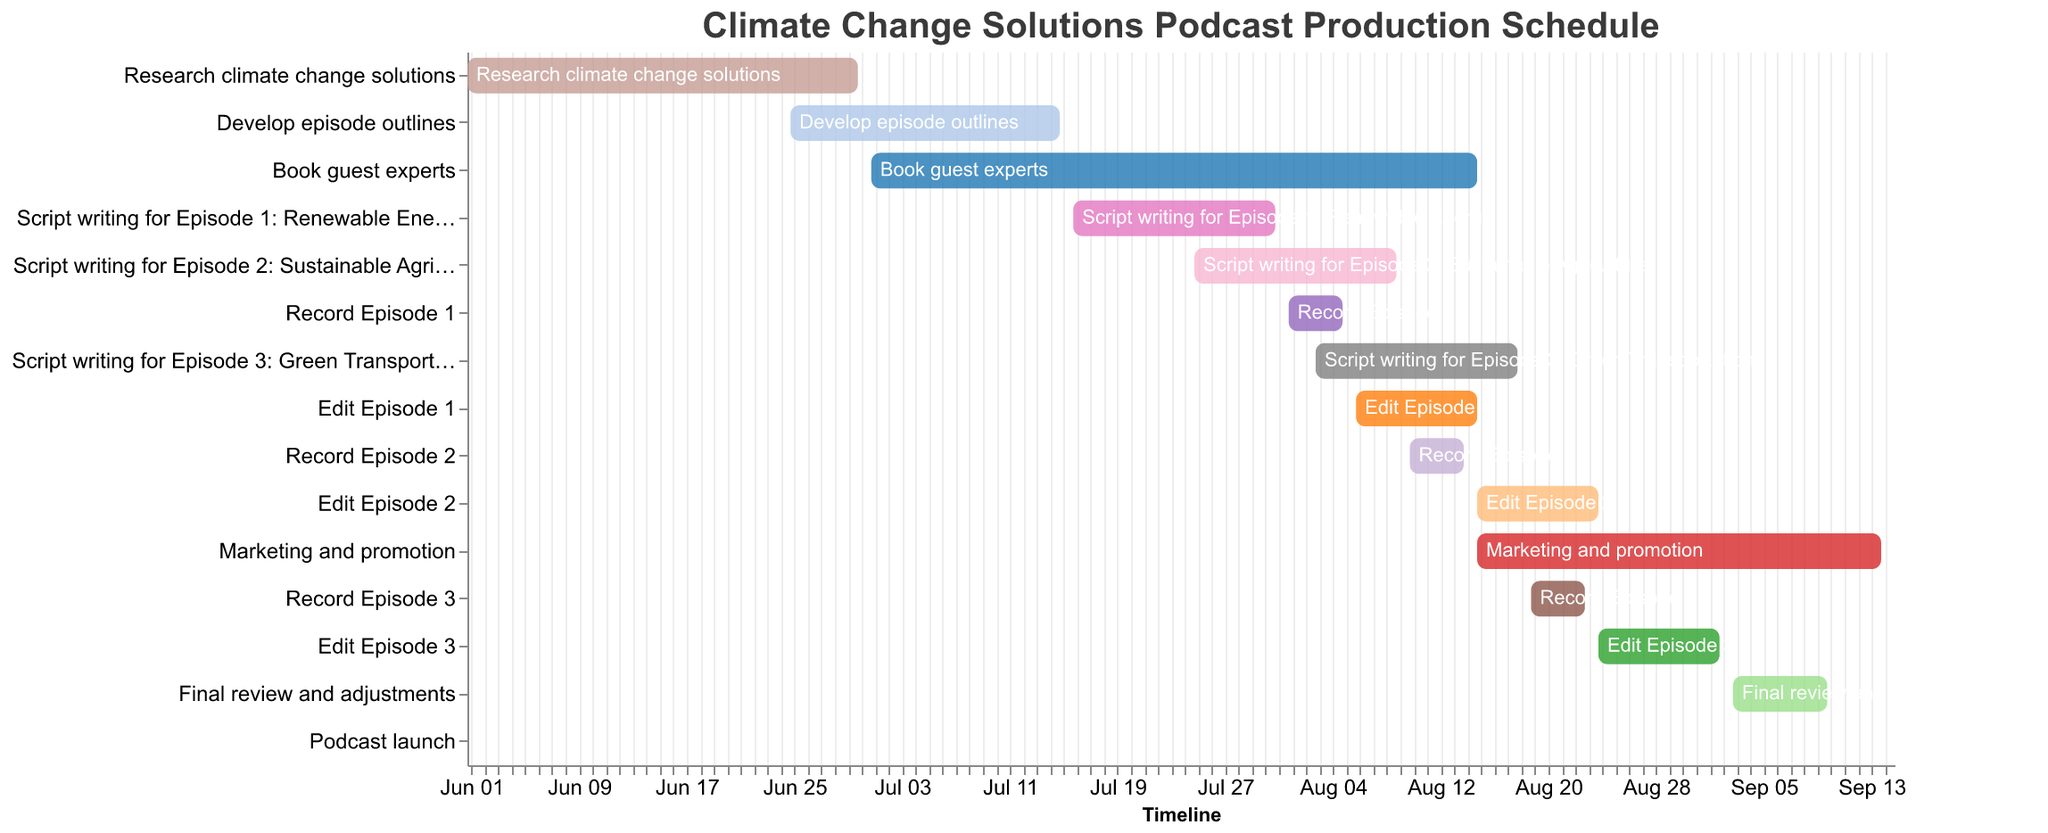How long is the research period for climate change solutions? According to the Gantt Chart, the research period starts on June 1, 2023, and ends on June 30, 2023. The number of days is calculated by finding the difference between these dates.
Answer: 30 days Which tasks are overlapping with the task of "Develop episode outlines"? The tasks listed from the Gantt Chart overlapping with "Develop episode outlines" which runs from June 25, 2023, to July 15, 2023, are "Research climate change solutions" (June 25-30, 2023) and "Book guest experts" (July 1-15, 2023).
Answer: "Research climate change solutions" and "Book guest experts" When does the "Marketing and promotion" task start, and when does it end? The Gantt Chart shows that the "Marketing and promotion" task starts on August 15, 2023, and ends on September 14, 2023.
Answer: August 15, 2023, to September 14, 2023 How many days are allocated for writing the script for Episode 3: Green Transportation? The script writing for Episode 3 starts on August 3, 2023, and ends on August 18, 2023. The number of days is calculated by finding the difference between these dates.
Answer: 16 days Which task has the shortest duration in the entire production schedule? Scanning the Gantt Chart, the task "Podcast launch" is the shortest, as it occurs only on September 15, 2023.
Answer: Podcast launch How long is the editing period for Episode 1 compared to Episode 3? The editing period for Episode 1 is from August 6, 2023, to August 15, 2023, totaling 10 days. For Episode 3, it is from August 24, 2023, to September 2, 2023, also totaling 10 days. Comparing these durations reveals that they are equal.
Answer: Equal Which task commences directly after the completion of recording Episode 1? According to the Gantt Chart, the recording of Episode 1 ends on August 5, 2023, and immediately after that date (on August 6, 2023), the editing of Episode 1 begins.
Answer: Edit Episode 1 What is the total duration of the podcast production schedule from the start of research to the launch? The production schedule starts with "Research climate change solutions" on June 1, 2023, and ends with the "Podcast launch" on September 15, 2023. Calculating the total duration from start to end gives the number of days.
Answer: 107 days Which two tasks are running concurrently between August 24, 2023, and September 2, 2023? The Gantt Chart shows "Edit Episode 3" (August 24, 2023, to September 2, 2023) and "Marketing and promotion" (August 15, 2023, to September 14, 2023) concurrently within this period.
Answer: Edit Episode 3 and Marketing and promotion 